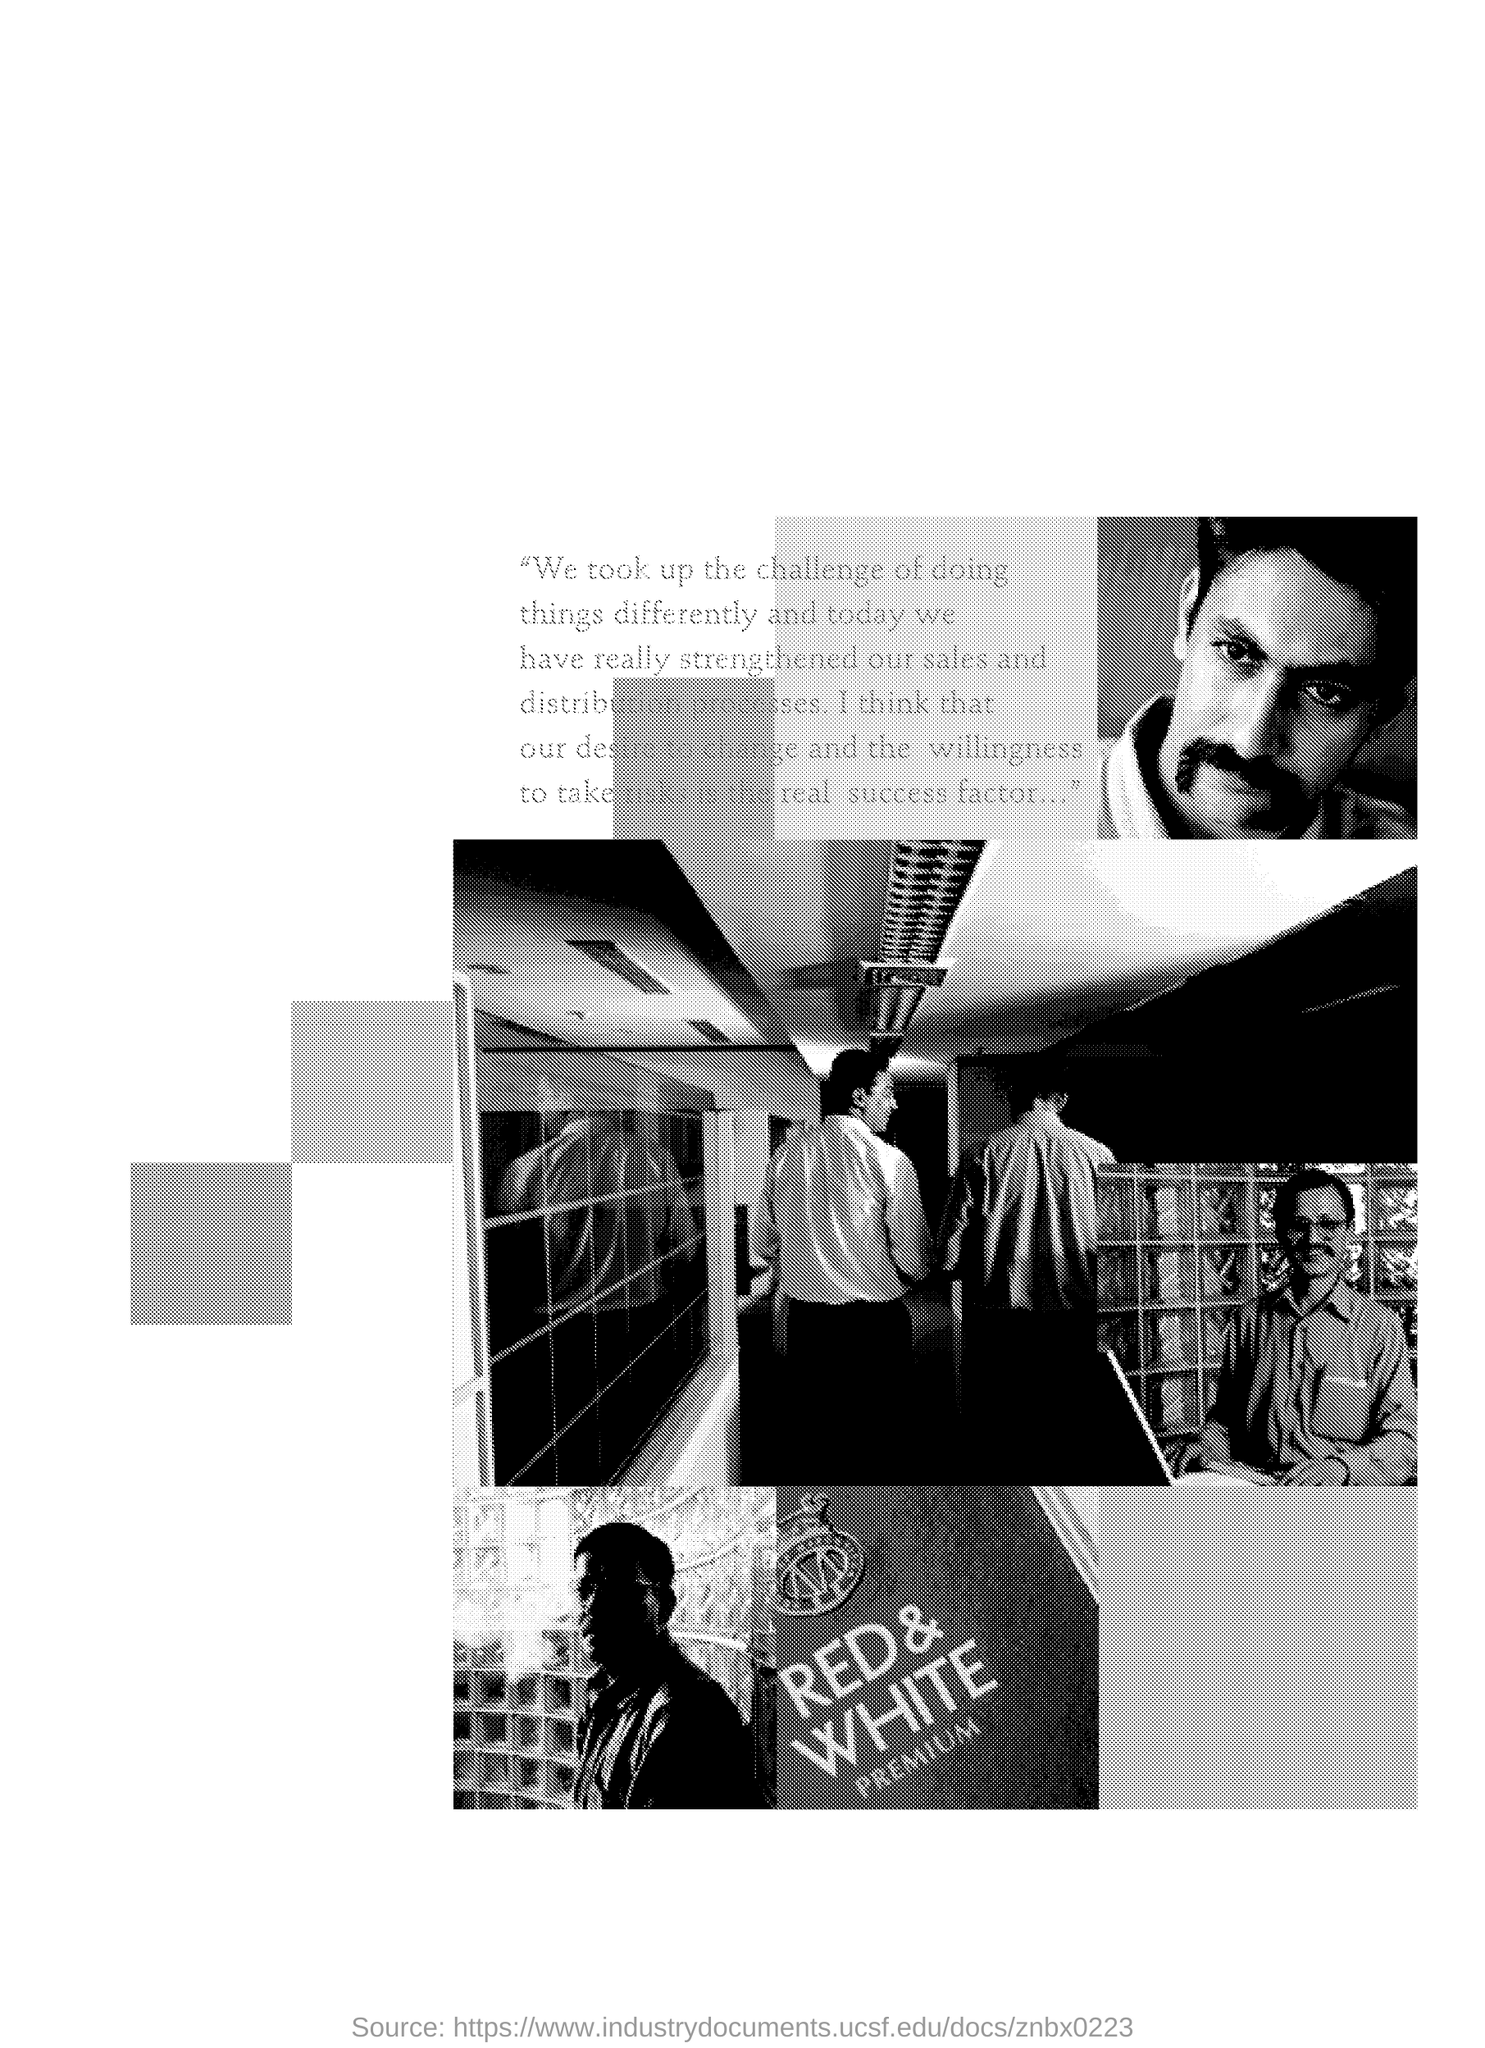What brand is mentioned in the document ?
Offer a very short reply. Red & White premium. 